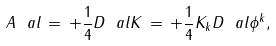Convert formula to latex. <formula><loc_0><loc_0><loc_500><loc_500>A _ { \ } a l \, = \, + \frac { 1 } { 4 } D _ { \ } a l K \, = \, + \frac { 1 } { 4 } K _ { k } D _ { \ } a l { \phi } ^ { k } ,</formula> 